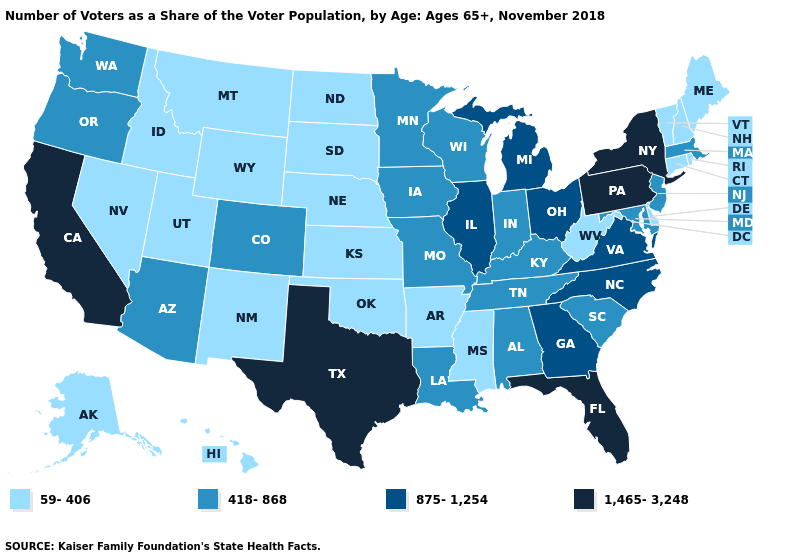Is the legend a continuous bar?
Write a very short answer. No. Name the states that have a value in the range 59-406?
Keep it brief. Alaska, Arkansas, Connecticut, Delaware, Hawaii, Idaho, Kansas, Maine, Mississippi, Montana, Nebraska, Nevada, New Hampshire, New Mexico, North Dakota, Oklahoma, Rhode Island, South Dakota, Utah, Vermont, West Virginia, Wyoming. What is the value of Mississippi?
Keep it brief. 59-406. Is the legend a continuous bar?
Keep it brief. No. Which states have the lowest value in the South?
Answer briefly. Arkansas, Delaware, Mississippi, Oklahoma, West Virginia. Name the states that have a value in the range 1,465-3,248?
Short answer required. California, Florida, New York, Pennsylvania, Texas. What is the highest value in states that border Washington?
Write a very short answer. 418-868. What is the highest value in states that border Utah?
Be succinct. 418-868. What is the value of Oregon?
Give a very brief answer. 418-868. Name the states that have a value in the range 1,465-3,248?
Keep it brief. California, Florida, New York, Pennsylvania, Texas. Does Wisconsin have the highest value in the MidWest?
Quick response, please. No. How many symbols are there in the legend?
Be succinct. 4. Name the states that have a value in the range 418-868?
Concise answer only. Alabama, Arizona, Colorado, Indiana, Iowa, Kentucky, Louisiana, Maryland, Massachusetts, Minnesota, Missouri, New Jersey, Oregon, South Carolina, Tennessee, Washington, Wisconsin. Does California have the highest value in the USA?
Be succinct. Yes. Does the map have missing data?
Keep it brief. No. 